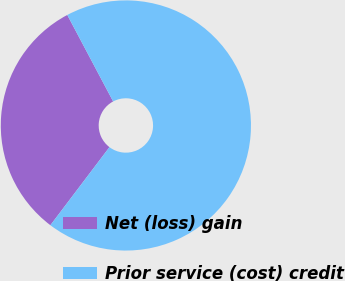Convert chart. <chart><loc_0><loc_0><loc_500><loc_500><pie_chart><fcel>Net (loss) gain<fcel>Prior service (cost) credit<nl><fcel>31.93%<fcel>68.07%<nl></chart> 